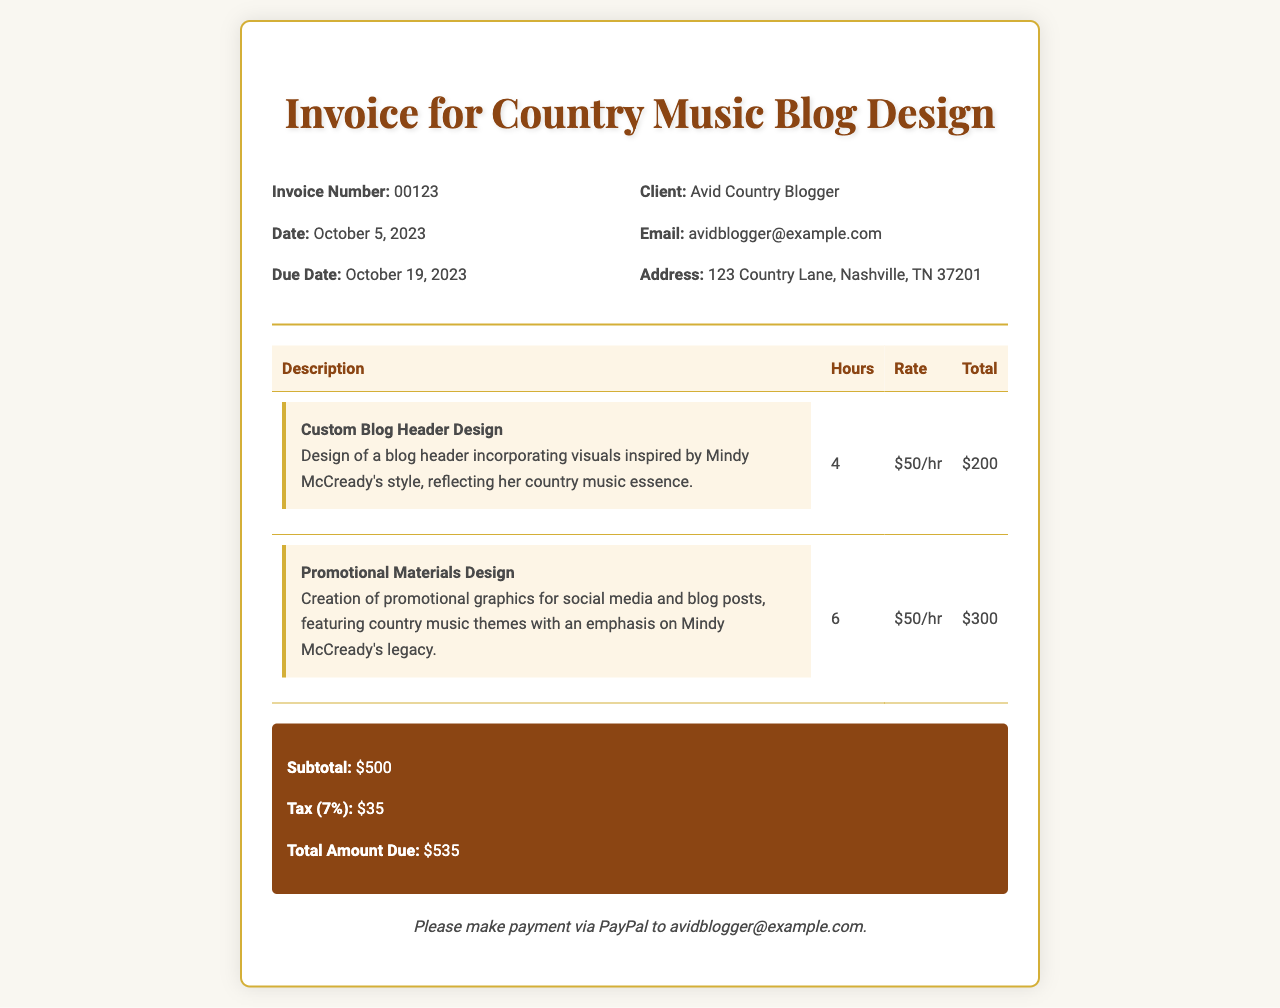What is the invoice number? The invoice number is stated clearly in the document, identified as 00123.
Answer: 00123 What is the total amount due? The total amount due is calculated and presented at the bottom of the document as $535.
Answer: $535 Who is the client? The client's name is mentioned at the top of the invoice, which is Avid Country Blogger.
Answer: Avid Country Blogger What service has the highest amount billed? By examining the services detailed, the Promotional Materials Design costs $300, which is the highest amount billed.
Answer: Promotional Materials Design What is the due date for the payment? The due date is specified in the invoice as October 19, 2023.
Answer: October 19, 2023 How much time was spent on the Custom Blog Header Design? The invoice details the hours assigned to the Custom Blog Header Design as 4 hours.
Answer: 4 What percentage is the tax applied to the subtotal? The document states that the tax applied is 7%.
Answer: 7% Which payment method is suggested for settling the invoice? The preferred payment method indicated in the invoice is PayPal.
Answer: PayPal What date was the invoice issued? The invoice issuance date is noted as October 5, 2023.
Answer: October 5, 2023 